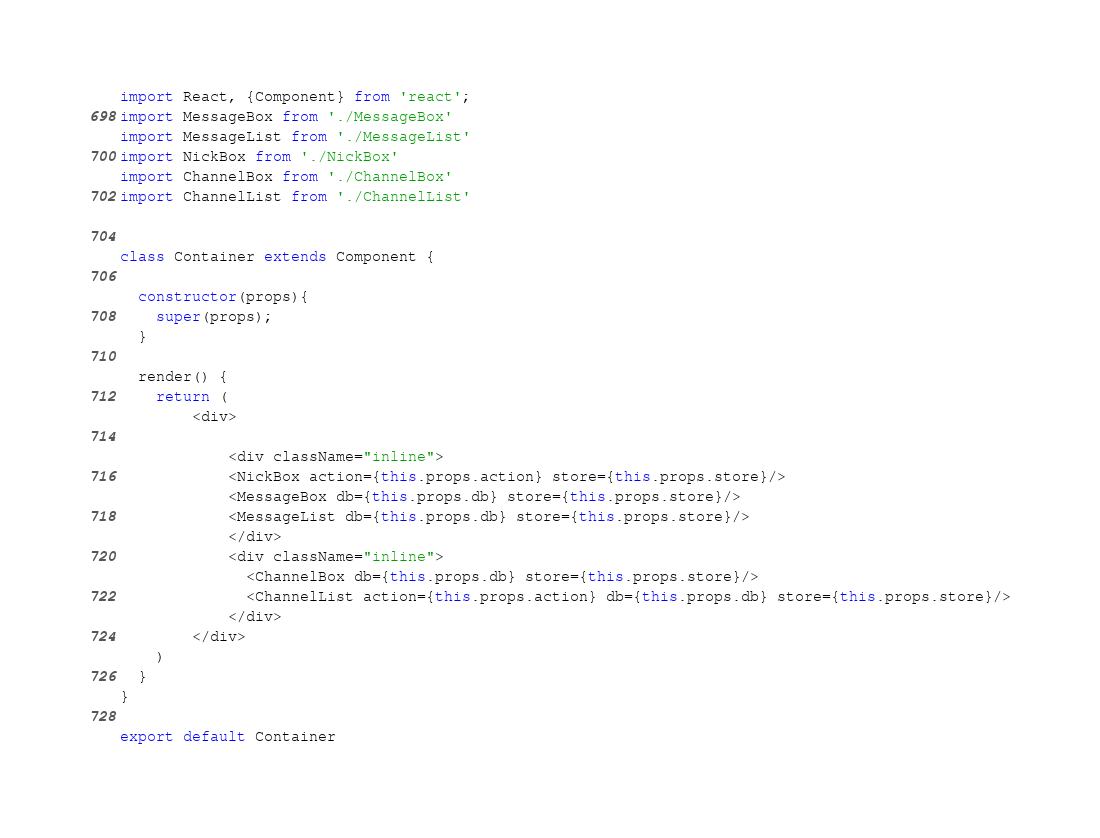<code> <loc_0><loc_0><loc_500><loc_500><_JavaScript_>import React, {Component} from 'react';
import MessageBox from './MessageBox'
import MessageList from './MessageList'
import NickBox from './NickBox'
import ChannelBox from './ChannelBox'
import ChannelList from './ChannelList'


class Container extends Component {

  constructor(props){
    super(props);
  }

  render() {
    return (
        <div>
          
            <div className="inline">
            <NickBox action={this.props.action} store={this.props.store}/>
            <MessageBox db={this.props.db} store={this.props.store}/>
            <MessageList db={this.props.db} store={this.props.store}/>
            </div>
            <div className="inline">
              <ChannelBox db={this.props.db} store={this.props.store}/>
              <ChannelList action={this.props.action} db={this.props.db} store={this.props.store}/>
            </div>
        </div>
    )
  }
}

export default Container</code> 